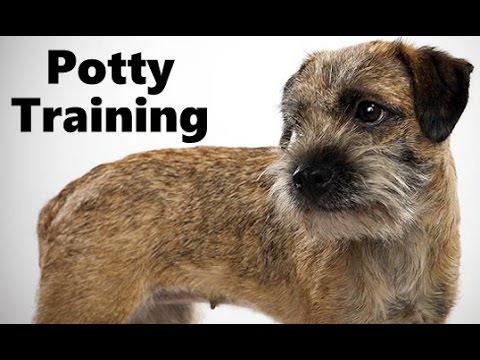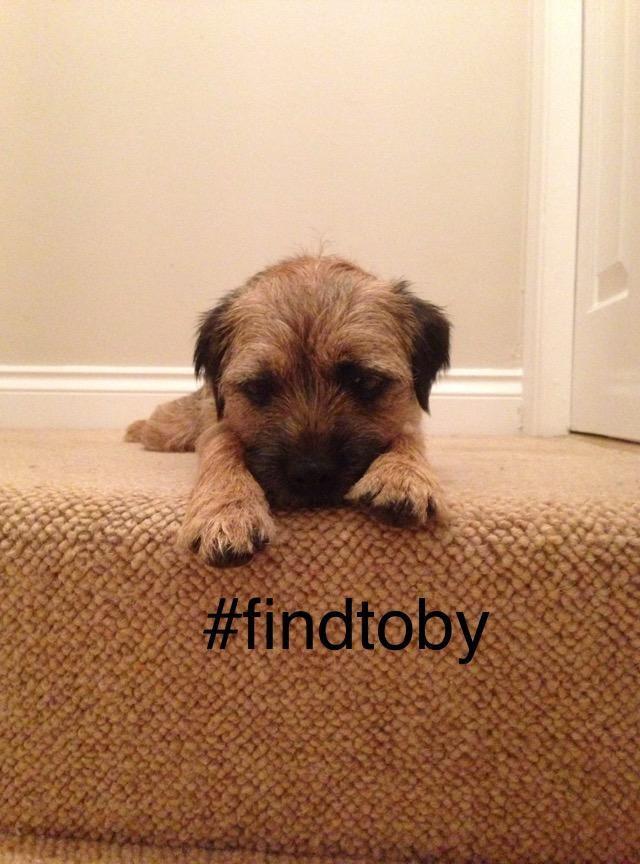The first image is the image on the left, the second image is the image on the right. Examine the images to the left and right. Is the description "The dog in the image on the right, he is not laying down." accurate? Answer yes or no. No. The first image is the image on the left, the second image is the image on the right. Given the left and right images, does the statement "the dog is laying down on the right side pic" hold true? Answer yes or no. Yes. 